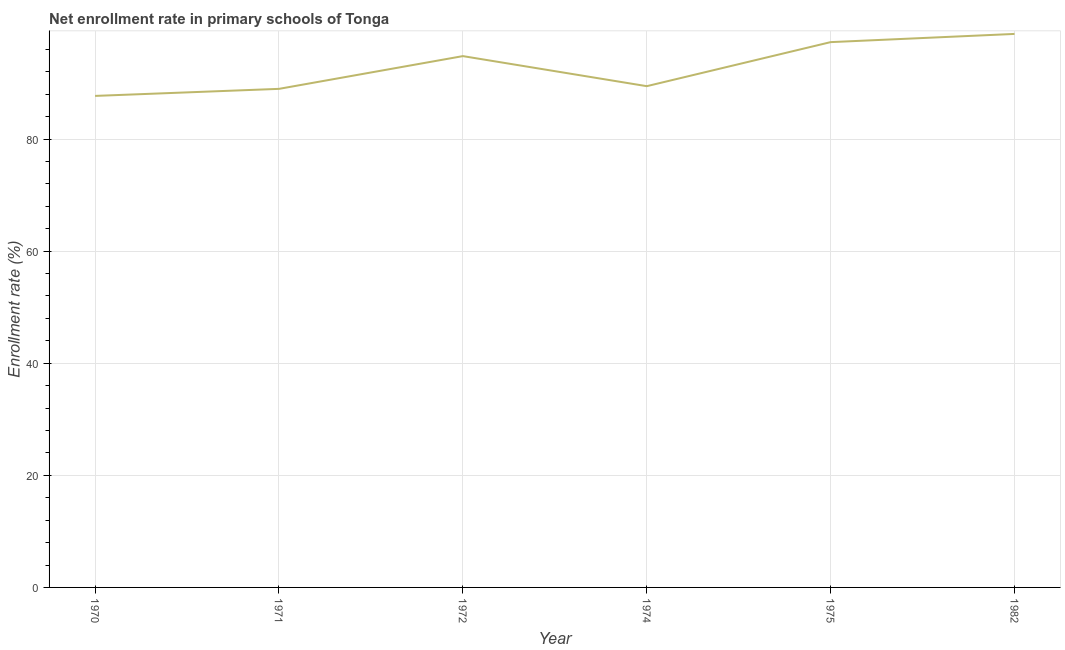What is the net enrollment rate in primary schools in 1975?
Make the answer very short. 97.28. Across all years, what is the maximum net enrollment rate in primary schools?
Your answer should be very brief. 98.75. Across all years, what is the minimum net enrollment rate in primary schools?
Offer a very short reply. 87.69. In which year was the net enrollment rate in primary schools maximum?
Provide a succinct answer. 1982. What is the sum of the net enrollment rate in primary schools?
Your response must be concise. 556.89. What is the difference between the net enrollment rate in primary schools in 1970 and 1974?
Offer a terse response. -1.74. What is the average net enrollment rate in primary schools per year?
Provide a short and direct response. 92.81. What is the median net enrollment rate in primary schools?
Your answer should be compact. 92.11. Do a majority of the years between 1975 and 1971 (inclusive) have net enrollment rate in primary schools greater than 20 %?
Keep it short and to the point. Yes. What is the ratio of the net enrollment rate in primary schools in 1974 to that in 1982?
Give a very brief answer. 0.91. What is the difference between the highest and the second highest net enrollment rate in primary schools?
Your answer should be very brief. 1.46. Is the sum of the net enrollment rate in primary schools in 1971 and 1974 greater than the maximum net enrollment rate in primary schools across all years?
Your response must be concise. Yes. What is the difference between the highest and the lowest net enrollment rate in primary schools?
Offer a terse response. 11.06. How many years are there in the graph?
Give a very brief answer. 6. What is the difference between two consecutive major ticks on the Y-axis?
Give a very brief answer. 20. What is the title of the graph?
Make the answer very short. Net enrollment rate in primary schools of Tonga. What is the label or title of the Y-axis?
Your answer should be very brief. Enrollment rate (%). What is the Enrollment rate (%) in 1970?
Offer a very short reply. 87.69. What is the Enrollment rate (%) of 1971?
Your answer should be very brief. 88.95. What is the Enrollment rate (%) of 1972?
Your response must be concise. 94.79. What is the Enrollment rate (%) of 1974?
Offer a terse response. 89.43. What is the Enrollment rate (%) in 1975?
Provide a short and direct response. 97.28. What is the Enrollment rate (%) of 1982?
Give a very brief answer. 98.75. What is the difference between the Enrollment rate (%) in 1970 and 1971?
Your answer should be very brief. -1.26. What is the difference between the Enrollment rate (%) in 1970 and 1972?
Offer a terse response. -7.1. What is the difference between the Enrollment rate (%) in 1970 and 1974?
Keep it short and to the point. -1.74. What is the difference between the Enrollment rate (%) in 1970 and 1975?
Your response must be concise. -9.59. What is the difference between the Enrollment rate (%) in 1970 and 1982?
Ensure brevity in your answer.  -11.06. What is the difference between the Enrollment rate (%) in 1971 and 1972?
Keep it short and to the point. -5.84. What is the difference between the Enrollment rate (%) in 1971 and 1974?
Offer a terse response. -0.48. What is the difference between the Enrollment rate (%) in 1971 and 1975?
Give a very brief answer. -8.34. What is the difference between the Enrollment rate (%) in 1971 and 1982?
Your answer should be very brief. -9.8. What is the difference between the Enrollment rate (%) in 1972 and 1974?
Make the answer very short. 5.36. What is the difference between the Enrollment rate (%) in 1972 and 1975?
Your answer should be very brief. -2.49. What is the difference between the Enrollment rate (%) in 1972 and 1982?
Your answer should be very brief. -3.96. What is the difference between the Enrollment rate (%) in 1974 and 1975?
Ensure brevity in your answer.  -7.86. What is the difference between the Enrollment rate (%) in 1974 and 1982?
Keep it short and to the point. -9.32. What is the difference between the Enrollment rate (%) in 1975 and 1982?
Ensure brevity in your answer.  -1.46. What is the ratio of the Enrollment rate (%) in 1970 to that in 1971?
Provide a succinct answer. 0.99. What is the ratio of the Enrollment rate (%) in 1970 to that in 1972?
Ensure brevity in your answer.  0.93. What is the ratio of the Enrollment rate (%) in 1970 to that in 1975?
Your answer should be very brief. 0.9. What is the ratio of the Enrollment rate (%) in 1970 to that in 1982?
Ensure brevity in your answer.  0.89. What is the ratio of the Enrollment rate (%) in 1971 to that in 1972?
Give a very brief answer. 0.94. What is the ratio of the Enrollment rate (%) in 1971 to that in 1974?
Provide a short and direct response. 0.99. What is the ratio of the Enrollment rate (%) in 1971 to that in 1975?
Your answer should be very brief. 0.91. What is the ratio of the Enrollment rate (%) in 1971 to that in 1982?
Your answer should be very brief. 0.9. What is the ratio of the Enrollment rate (%) in 1972 to that in 1974?
Provide a short and direct response. 1.06. What is the ratio of the Enrollment rate (%) in 1972 to that in 1975?
Ensure brevity in your answer.  0.97. What is the ratio of the Enrollment rate (%) in 1974 to that in 1975?
Provide a short and direct response. 0.92. What is the ratio of the Enrollment rate (%) in 1974 to that in 1982?
Make the answer very short. 0.91. What is the ratio of the Enrollment rate (%) in 1975 to that in 1982?
Make the answer very short. 0.98. 